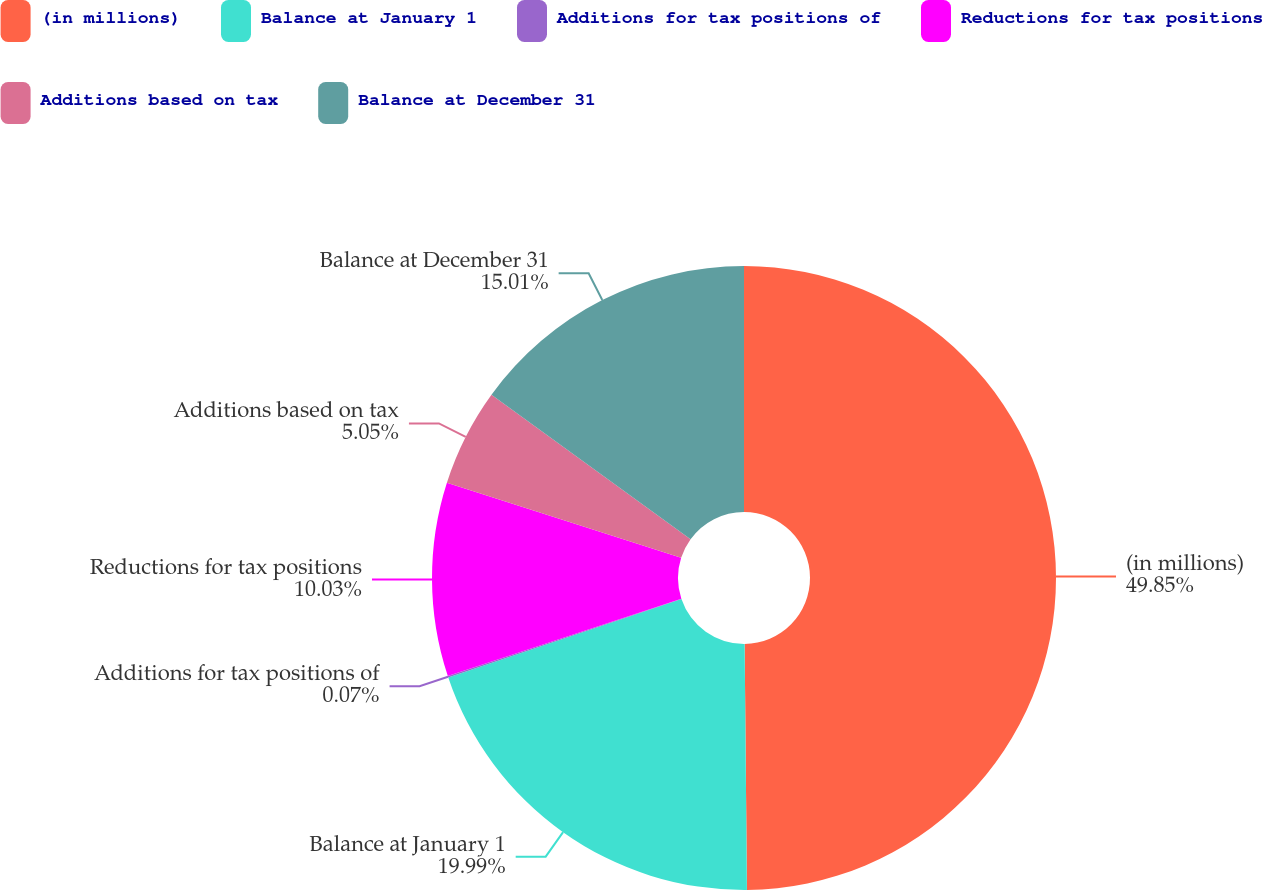Convert chart to OTSL. <chart><loc_0><loc_0><loc_500><loc_500><pie_chart><fcel>(in millions)<fcel>Balance at January 1<fcel>Additions for tax positions of<fcel>Reductions for tax positions<fcel>Additions based on tax<fcel>Balance at December 31<nl><fcel>49.85%<fcel>19.99%<fcel>0.07%<fcel>10.03%<fcel>5.05%<fcel>15.01%<nl></chart> 